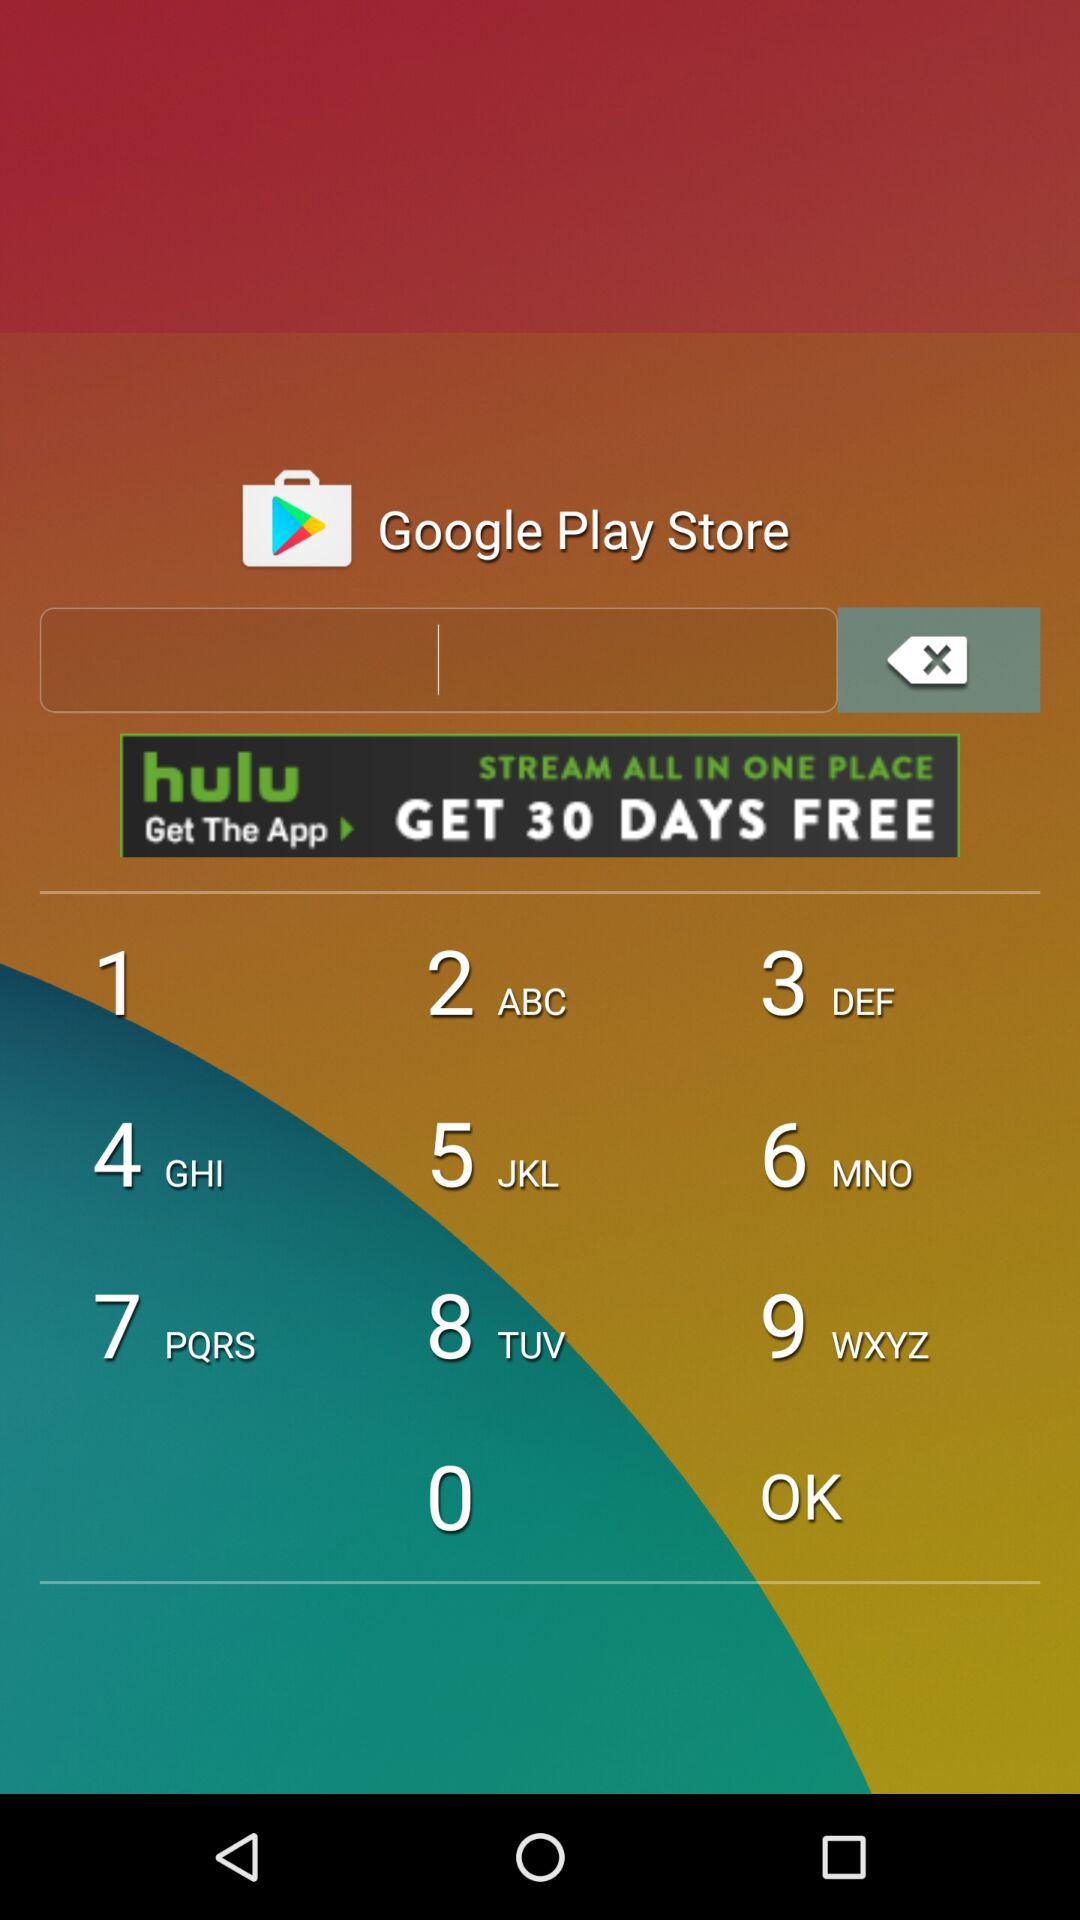How many pages are there in total? There are a total of 6 pages. 